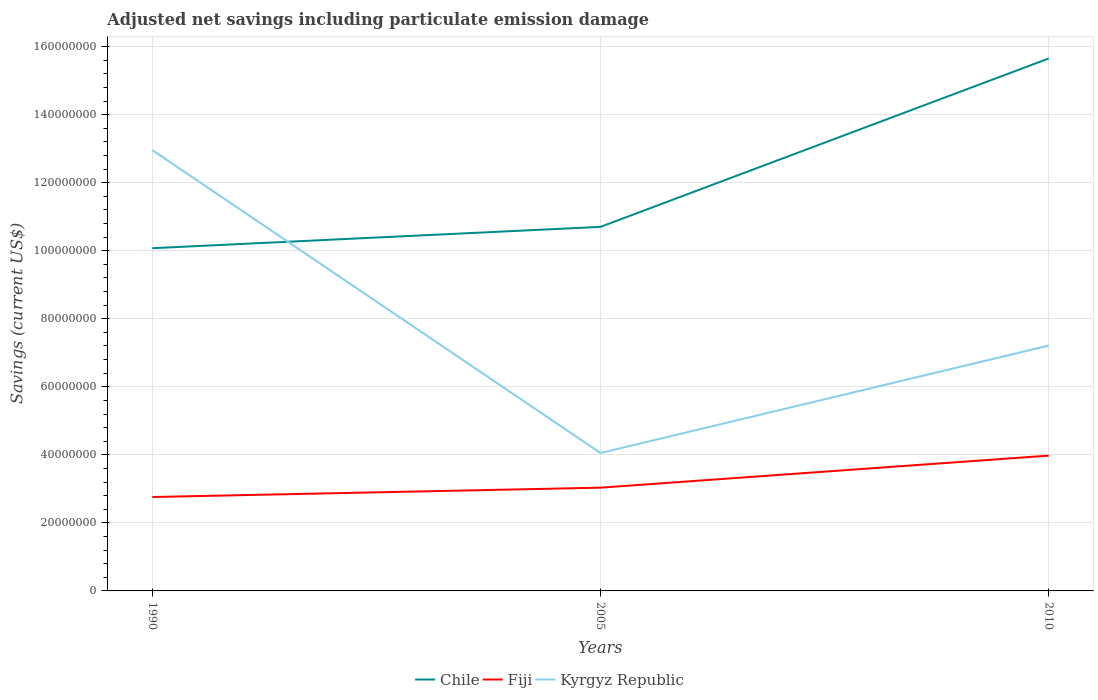Does the line corresponding to Kyrgyz Republic intersect with the line corresponding to Fiji?
Your answer should be very brief. No. Is the number of lines equal to the number of legend labels?
Offer a very short reply. Yes. Across all years, what is the maximum net savings in Kyrgyz Republic?
Offer a terse response. 4.05e+07. In which year was the net savings in Fiji maximum?
Provide a succinct answer. 1990. What is the total net savings in Chile in the graph?
Provide a short and direct response. -4.95e+07. What is the difference between the highest and the second highest net savings in Kyrgyz Republic?
Your response must be concise. 8.90e+07. How many years are there in the graph?
Ensure brevity in your answer.  3. Does the graph contain any zero values?
Make the answer very short. No. Does the graph contain grids?
Your answer should be compact. Yes. Where does the legend appear in the graph?
Give a very brief answer. Bottom center. How many legend labels are there?
Provide a succinct answer. 3. What is the title of the graph?
Make the answer very short. Adjusted net savings including particulate emission damage. Does "St. Kitts and Nevis" appear as one of the legend labels in the graph?
Give a very brief answer. No. What is the label or title of the Y-axis?
Provide a succinct answer. Savings (current US$). What is the Savings (current US$) in Chile in 1990?
Provide a short and direct response. 1.01e+08. What is the Savings (current US$) of Fiji in 1990?
Offer a terse response. 2.76e+07. What is the Savings (current US$) of Kyrgyz Republic in 1990?
Ensure brevity in your answer.  1.30e+08. What is the Savings (current US$) of Chile in 2005?
Your answer should be very brief. 1.07e+08. What is the Savings (current US$) of Fiji in 2005?
Offer a very short reply. 3.04e+07. What is the Savings (current US$) of Kyrgyz Republic in 2005?
Your response must be concise. 4.05e+07. What is the Savings (current US$) of Chile in 2010?
Your response must be concise. 1.56e+08. What is the Savings (current US$) in Fiji in 2010?
Your answer should be very brief. 3.98e+07. What is the Savings (current US$) of Kyrgyz Republic in 2010?
Your answer should be very brief. 7.21e+07. Across all years, what is the maximum Savings (current US$) in Chile?
Provide a succinct answer. 1.56e+08. Across all years, what is the maximum Savings (current US$) of Fiji?
Your response must be concise. 3.98e+07. Across all years, what is the maximum Savings (current US$) in Kyrgyz Republic?
Your answer should be very brief. 1.30e+08. Across all years, what is the minimum Savings (current US$) of Chile?
Make the answer very short. 1.01e+08. Across all years, what is the minimum Savings (current US$) in Fiji?
Your answer should be very brief. 2.76e+07. Across all years, what is the minimum Savings (current US$) of Kyrgyz Republic?
Make the answer very short. 4.05e+07. What is the total Savings (current US$) of Chile in the graph?
Offer a terse response. 3.64e+08. What is the total Savings (current US$) in Fiji in the graph?
Your answer should be very brief. 9.77e+07. What is the total Savings (current US$) of Kyrgyz Republic in the graph?
Provide a succinct answer. 2.42e+08. What is the difference between the Savings (current US$) of Chile in 1990 and that in 2005?
Provide a succinct answer. -6.27e+06. What is the difference between the Savings (current US$) in Fiji in 1990 and that in 2005?
Make the answer very short. -2.75e+06. What is the difference between the Savings (current US$) in Kyrgyz Republic in 1990 and that in 2005?
Make the answer very short. 8.90e+07. What is the difference between the Savings (current US$) of Chile in 1990 and that in 2010?
Offer a terse response. -5.58e+07. What is the difference between the Savings (current US$) of Fiji in 1990 and that in 2010?
Your answer should be very brief. -1.22e+07. What is the difference between the Savings (current US$) in Kyrgyz Republic in 1990 and that in 2010?
Make the answer very short. 5.75e+07. What is the difference between the Savings (current US$) of Chile in 2005 and that in 2010?
Your answer should be compact. -4.95e+07. What is the difference between the Savings (current US$) in Fiji in 2005 and that in 2010?
Make the answer very short. -9.42e+06. What is the difference between the Savings (current US$) in Kyrgyz Republic in 2005 and that in 2010?
Keep it short and to the point. -3.16e+07. What is the difference between the Savings (current US$) of Chile in 1990 and the Savings (current US$) of Fiji in 2005?
Keep it short and to the point. 7.04e+07. What is the difference between the Savings (current US$) in Chile in 1990 and the Savings (current US$) in Kyrgyz Republic in 2005?
Make the answer very short. 6.02e+07. What is the difference between the Savings (current US$) of Fiji in 1990 and the Savings (current US$) of Kyrgyz Republic in 2005?
Provide a succinct answer. -1.29e+07. What is the difference between the Savings (current US$) of Chile in 1990 and the Savings (current US$) of Fiji in 2010?
Offer a very short reply. 6.10e+07. What is the difference between the Savings (current US$) in Chile in 1990 and the Savings (current US$) in Kyrgyz Republic in 2010?
Your answer should be very brief. 2.86e+07. What is the difference between the Savings (current US$) in Fiji in 1990 and the Savings (current US$) in Kyrgyz Republic in 2010?
Offer a terse response. -4.45e+07. What is the difference between the Savings (current US$) in Chile in 2005 and the Savings (current US$) in Fiji in 2010?
Offer a terse response. 6.72e+07. What is the difference between the Savings (current US$) of Chile in 2005 and the Savings (current US$) of Kyrgyz Republic in 2010?
Provide a short and direct response. 3.49e+07. What is the difference between the Savings (current US$) of Fiji in 2005 and the Savings (current US$) of Kyrgyz Republic in 2010?
Your answer should be compact. -4.18e+07. What is the average Savings (current US$) in Chile per year?
Your answer should be very brief. 1.21e+08. What is the average Savings (current US$) in Fiji per year?
Offer a very short reply. 3.26e+07. What is the average Savings (current US$) of Kyrgyz Republic per year?
Offer a terse response. 8.07e+07. In the year 1990, what is the difference between the Savings (current US$) in Chile and Savings (current US$) in Fiji?
Ensure brevity in your answer.  7.31e+07. In the year 1990, what is the difference between the Savings (current US$) of Chile and Savings (current US$) of Kyrgyz Republic?
Provide a short and direct response. -2.88e+07. In the year 1990, what is the difference between the Savings (current US$) in Fiji and Savings (current US$) in Kyrgyz Republic?
Provide a succinct answer. -1.02e+08. In the year 2005, what is the difference between the Savings (current US$) in Chile and Savings (current US$) in Fiji?
Your answer should be very brief. 7.67e+07. In the year 2005, what is the difference between the Savings (current US$) in Chile and Savings (current US$) in Kyrgyz Republic?
Provide a short and direct response. 6.65e+07. In the year 2005, what is the difference between the Savings (current US$) of Fiji and Savings (current US$) of Kyrgyz Republic?
Your answer should be very brief. -1.02e+07. In the year 2010, what is the difference between the Savings (current US$) of Chile and Savings (current US$) of Fiji?
Make the answer very short. 1.17e+08. In the year 2010, what is the difference between the Savings (current US$) of Chile and Savings (current US$) of Kyrgyz Republic?
Provide a succinct answer. 8.44e+07. In the year 2010, what is the difference between the Savings (current US$) of Fiji and Savings (current US$) of Kyrgyz Republic?
Ensure brevity in your answer.  -3.23e+07. What is the ratio of the Savings (current US$) in Chile in 1990 to that in 2005?
Provide a succinct answer. 0.94. What is the ratio of the Savings (current US$) in Fiji in 1990 to that in 2005?
Your answer should be very brief. 0.91. What is the ratio of the Savings (current US$) of Kyrgyz Republic in 1990 to that in 2005?
Give a very brief answer. 3.2. What is the ratio of the Savings (current US$) of Chile in 1990 to that in 2010?
Make the answer very short. 0.64. What is the ratio of the Savings (current US$) in Fiji in 1990 to that in 2010?
Provide a short and direct response. 0.69. What is the ratio of the Savings (current US$) in Kyrgyz Republic in 1990 to that in 2010?
Keep it short and to the point. 1.8. What is the ratio of the Savings (current US$) in Chile in 2005 to that in 2010?
Your response must be concise. 0.68. What is the ratio of the Savings (current US$) in Fiji in 2005 to that in 2010?
Your answer should be very brief. 0.76. What is the ratio of the Savings (current US$) of Kyrgyz Republic in 2005 to that in 2010?
Ensure brevity in your answer.  0.56. What is the difference between the highest and the second highest Savings (current US$) in Chile?
Your answer should be very brief. 4.95e+07. What is the difference between the highest and the second highest Savings (current US$) in Fiji?
Your response must be concise. 9.42e+06. What is the difference between the highest and the second highest Savings (current US$) in Kyrgyz Republic?
Make the answer very short. 5.75e+07. What is the difference between the highest and the lowest Savings (current US$) of Chile?
Make the answer very short. 5.58e+07. What is the difference between the highest and the lowest Savings (current US$) of Fiji?
Provide a succinct answer. 1.22e+07. What is the difference between the highest and the lowest Savings (current US$) of Kyrgyz Republic?
Make the answer very short. 8.90e+07. 